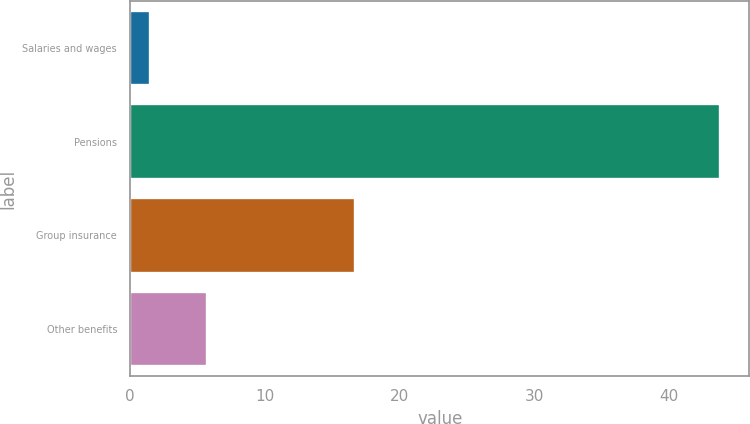Convert chart. <chart><loc_0><loc_0><loc_500><loc_500><bar_chart><fcel>Salaries and wages<fcel>Pensions<fcel>Group insurance<fcel>Other benefits<nl><fcel>1.5<fcel>43.8<fcel>16.7<fcel>5.73<nl></chart> 